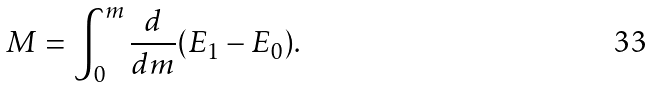Convert formula to latex. <formula><loc_0><loc_0><loc_500><loc_500>M = \int _ { 0 } ^ { m } \frac { d } { d m } ( E _ { 1 } - E _ { 0 } ) .</formula> 